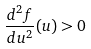<formula> <loc_0><loc_0><loc_500><loc_500>\frac { d ^ { 2 } f } { d u ^ { 2 } } ( u ) > 0</formula> 